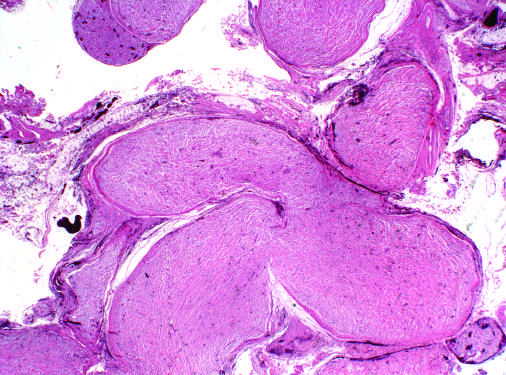re characteristic intranuclear inclusions expanded by infiltrating tumor cells?
Answer the question using a single word or phrase. No 